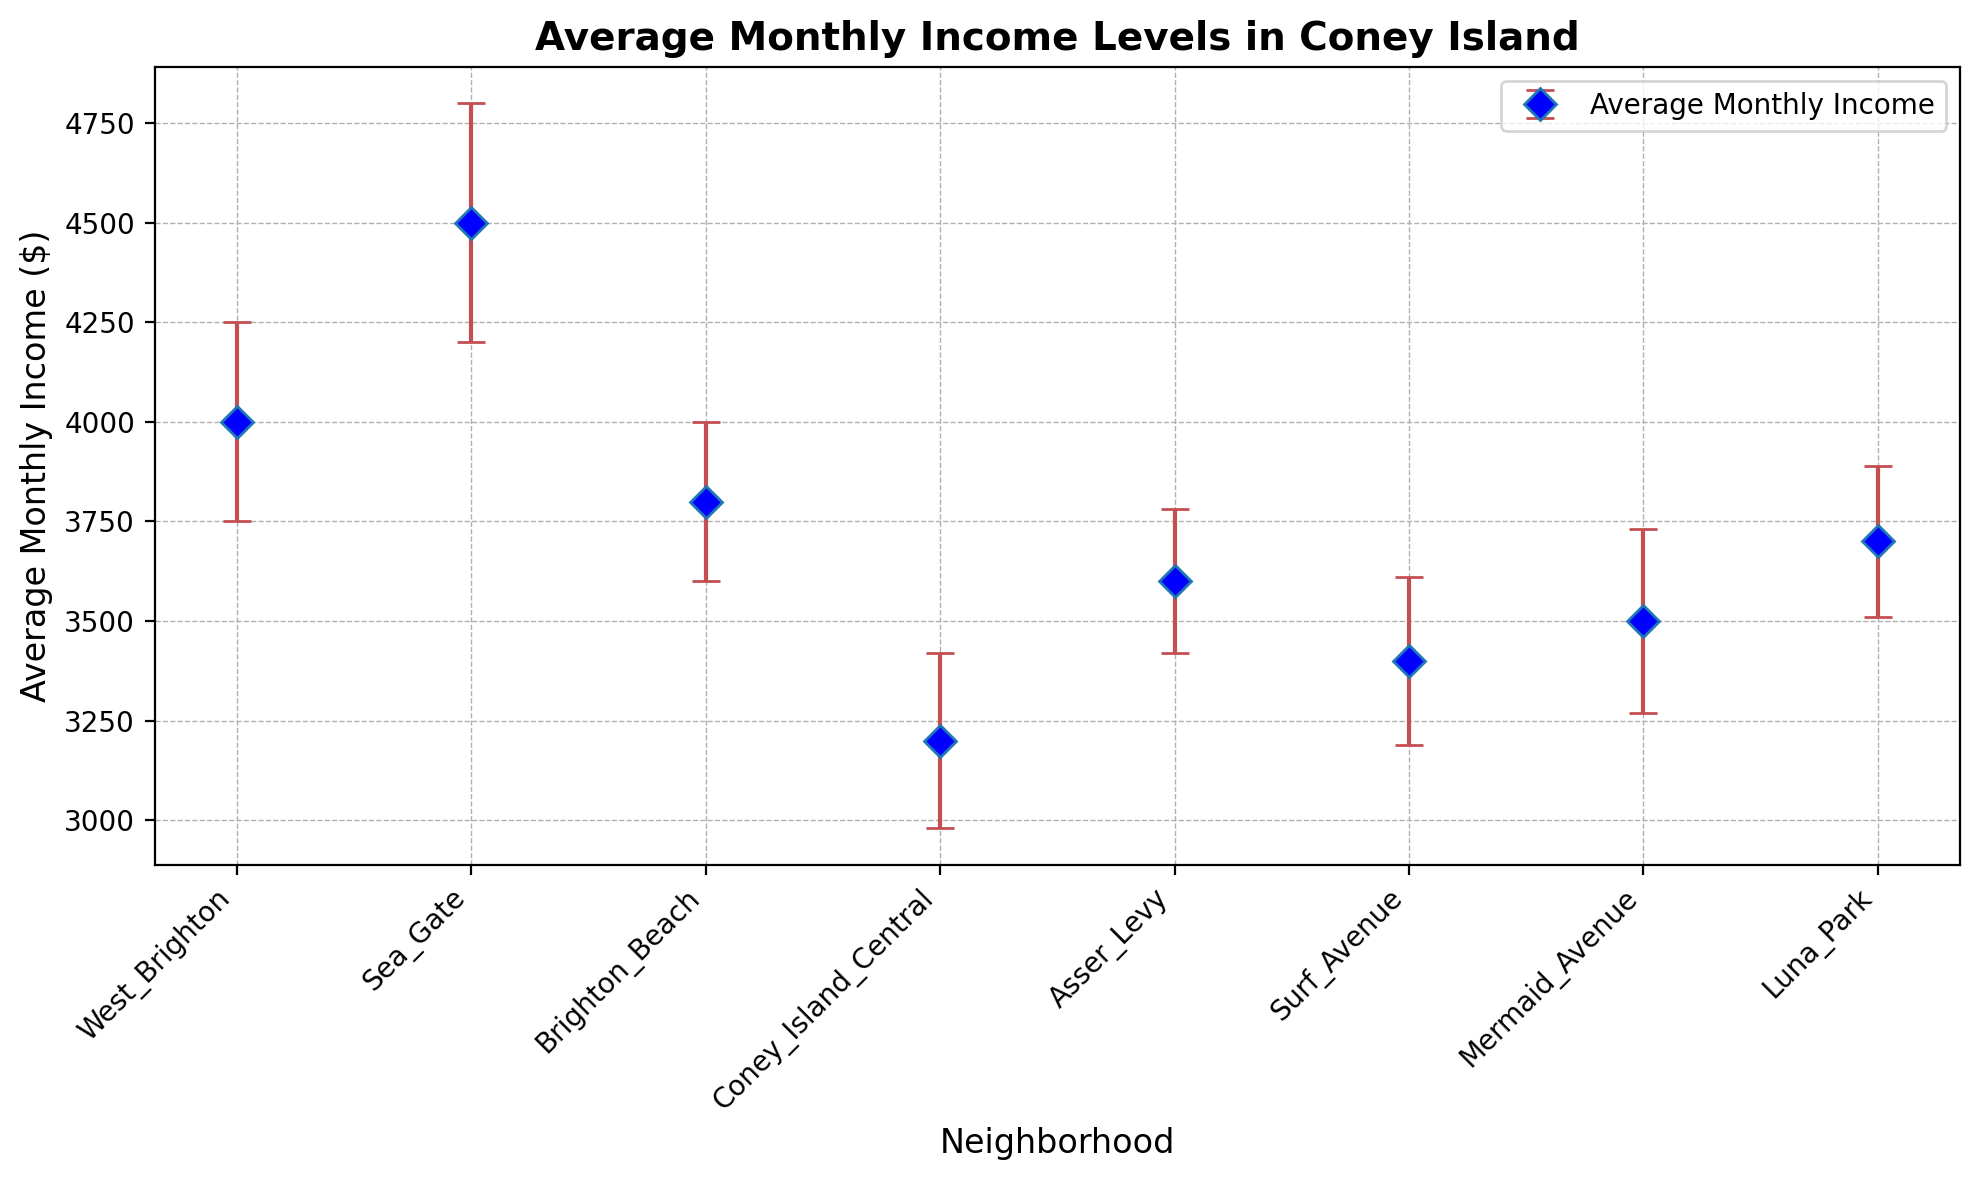What is the neighborhood with the highest average monthly income? Sea Gate has the highest average monthly income. This is indicated by the highest point on the plot among the neighborhoods.
Answer: Sea Gate What is the difference in average monthly income between Brighton Beach and Luna Park? The average monthly income in Brighton Beach is $3800 and in Luna Park is $3700. The difference is $3800 - $3700 = $100.
Answer: $100 Which neighborhood has the lowest average monthly income, and what is its value? Coney Island Central has the lowest average monthly income at $3200. This is indicated by the lowest point on the plot among the neighborhoods.
Answer: Coney Island Central, $3200 Are the income error margins in Sea Gate higher or lower than those in West Brighton? The error margin in Sea Gate is $300, while in West Brighton it is $250. Therefore, the error margin in Sea Gate is higher.
Answer: Higher What's the average of the average monthly incomes for Coney Island Central and Surf Avenue? The average monthly incomes are $3200 for Coney Island Central and $3400 for Surf Avenue. The average of these two values is ($3200 + $3400) / 2 = $3300.
Answer: $3300 Which neighborhood has the third highest average monthly income, and what is its value? West Brighton has the third highest average monthly income at $4000. This is determined by sorting the neighborhoods by their income levels.
Answer: West Brighton, $4000 Compare the average monthly income error margins for Mermaid Avenue and Asser Levy. Which one has a larger error margin? The error margin for Mermaid Avenue is $230, and for Asser Levy it is $180. So, Mermaid Avenue has a larger error margin.
Answer: Mermaid Avenue Is the average monthly income for Brighton Beach within the error margin of Sea Gate's average monthly income? Brighton Beach's average monthly income is $3800. The range for Sea Gate's income considering the error margin is $4500 ± $300, which is $4200 to $4800. Since $3800 is not within this range, it is not within the error margin of Sea Gate's income.
Answer: No What is the sum of the error margins for Coney Island Central and Luna Park? The error margin for Coney Island Central is $220 and for Luna Park is $190. The sum of these error margins is $220 + $190 = $410.
Answer: $410 Which neighborhoods have an average monthly income greater than $3500? Neighborhoods with average monthly incomes greater than $3500 are West Brighton ($4000), Sea Gate ($4500), Brighton Beach ($3800), Asser Levy ($3600), and Luna Park ($3700).
Answer: West Brighton, Sea Gate, Brighton Beach, Asser Levy, Luna Park 